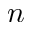Convert formula to latex. <formula><loc_0><loc_0><loc_500><loc_500>n</formula> 